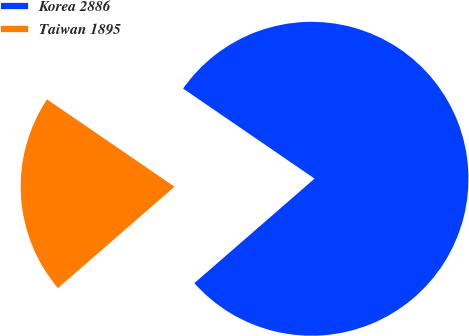Convert chart. <chart><loc_0><loc_0><loc_500><loc_500><pie_chart><fcel>Korea 2886<fcel>Taiwan 1895<nl><fcel>79.05%<fcel>20.95%<nl></chart> 